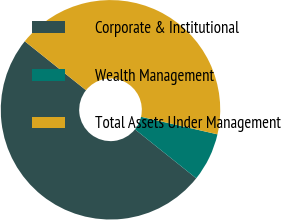Convert chart to OTSL. <chart><loc_0><loc_0><loc_500><loc_500><pie_chart><fcel>Corporate & Institutional<fcel>Wealth Management<fcel>Total Assets Under Management<nl><fcel>50.0%<fcel>7.14%<fcel>42.86%<nl></chart> 